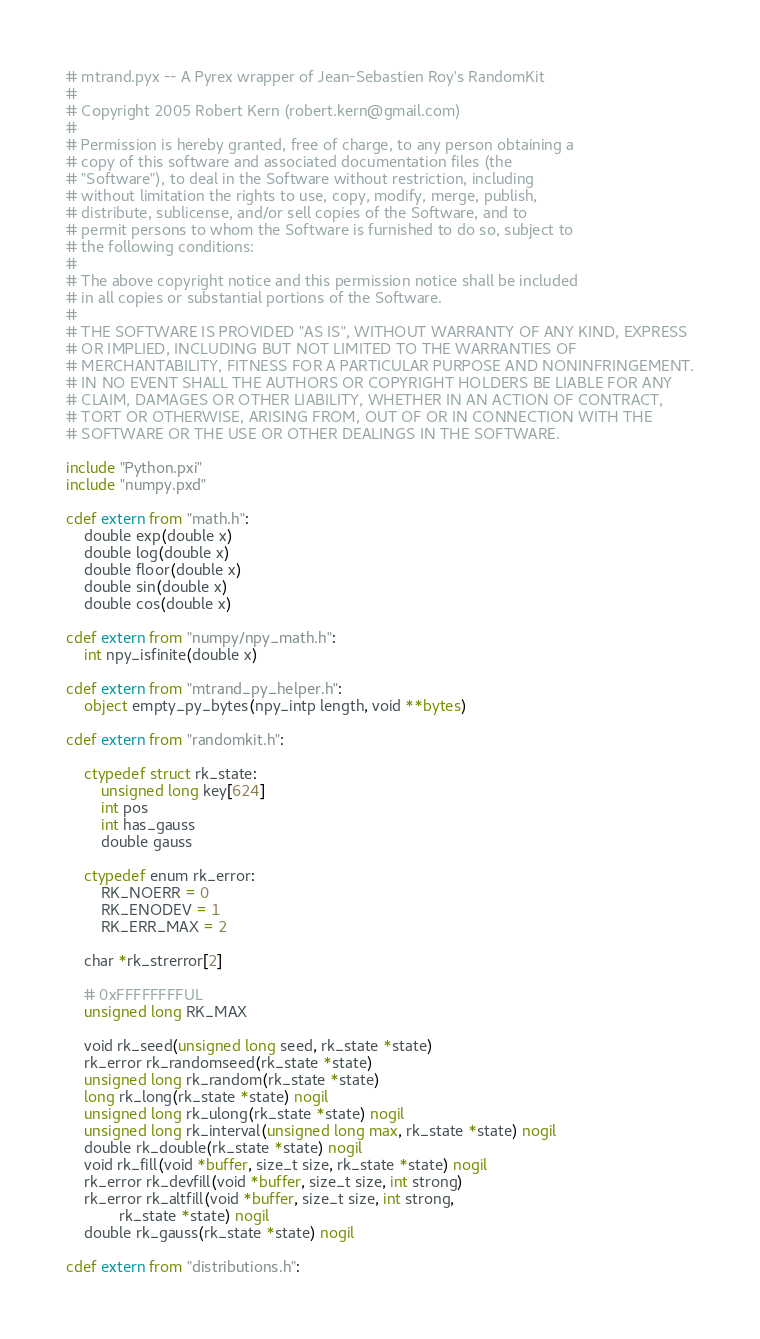Convert code to text. <code><loc_0><loc_0><loc_500><loc_500><_Cython_># mtrand.pyx -- A Pyrex wrapper of Jean-Sebastien Roy's RandomKit
#
# Copyright 2005 Robert Kern (robert.kern@gmail.com)
#
# Permission is hereby granted, free of charge, to any person obtaining a
# copy of this software and associated documentation files (the
# "Software"), to deal in the Software without restriction, including
# without limitation the rights to use, copy, modify, merge, publish,
# distribute, sublicense, and/or sell copies of the Software, and to
# permit persons to whom the Software is furnished to do so, subject to
# the following conditions:
#
# The above copyright notice and this permission notice shall be included
# in all copies or substantial portions of the Software.
#
# THE SOFTWARE IS PROVIDED "AS IS", WITHOUT WARRANTY OF ANY KIND, EXPRESS
# OR IMPLIED, INCLUDING BUT NOT LIMITED TO THE WARRANTIES OF
# MERCHANTABILITY, FITNESS FOR A PARTICULAR PURPOSE AND NONINFRINGEMENT.
# IN NO EVENT SHALL THE AUTHORS OR COPYRIGHT HOLDERS BE LIABLE FOR ANY
# CLAIM, DAMAGES OR OTHER LIABILITY, WHETHER IN AN ACTION OF CONTRACT,
# TORT OR OTHERWISE, ARISING FROM, OUT OF OR IN CONNECTION WITH THE
# SOFTWARE OR THE USE OR OTHER DEALINGS IN THE SOFTWARE.

include "Python.pxi"
include "numpy.pxd"

cdef extern from "math.h":
    double exp(double x)
    double log(double x)
    double floor(double x)
    double sin(double x)
    double cos(double x)

cdef extern from "numpy/npy_math.h":
    int npy_isfinite(double x)

cdef extern from "mtrand_py_helper.h":
    object empty_py_bytes(npy_intp length, void **bytes)

cdef extern from "randomkit.h":

    ctypedef struct rk_state:
        unsigned long key[624]
        int pos
        int has_gauss
        double gauss

    ctypedef enum rk_error:
        RK_NOERR = 0
        RK_ENODEV = 1
        RK_ERR_MAX = 2

    char *rk_strerror[2]

    # 0xFFFFFFFFUL
    unsigned long RK_MAX

    void rk_seed(unsigned long seed, rk_state *state)
    rk_error rk_randomseed(rk_state *state)
    unsigned long rk_random(rk_state *state)
    long rk_long(rk_state *state) nogil
    unsigned long rk_ulong(rk_state *state) nogil
    unsigned long rk_interval(unsigned long max, rk_state *state) nogil
    double rk_double(rk_state *state) nogil
    void rk_fill(void *buffer, size_t size, rk_state *state) nogil
    rk_error rk_devfill(void *buffer, size_t size, int strong)
    rk_error rk_altfill(void *buffer, size_t size, int strong,
            rk_state *state) nogil
    double rk_gauss(rk_state *state) nogil

cdef extern from "distributions.h":</code> 